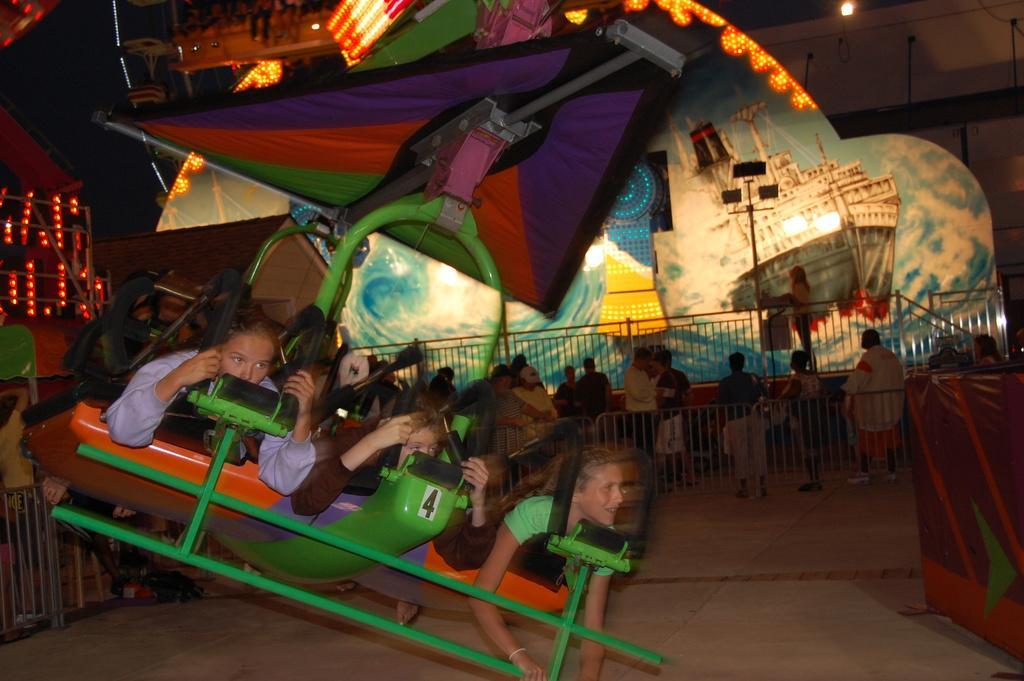In one or two sentences, can you explain what this image depicts? In this image I can see few kids taking ride in the exhibition, behind there is a fence, people and some other object. 